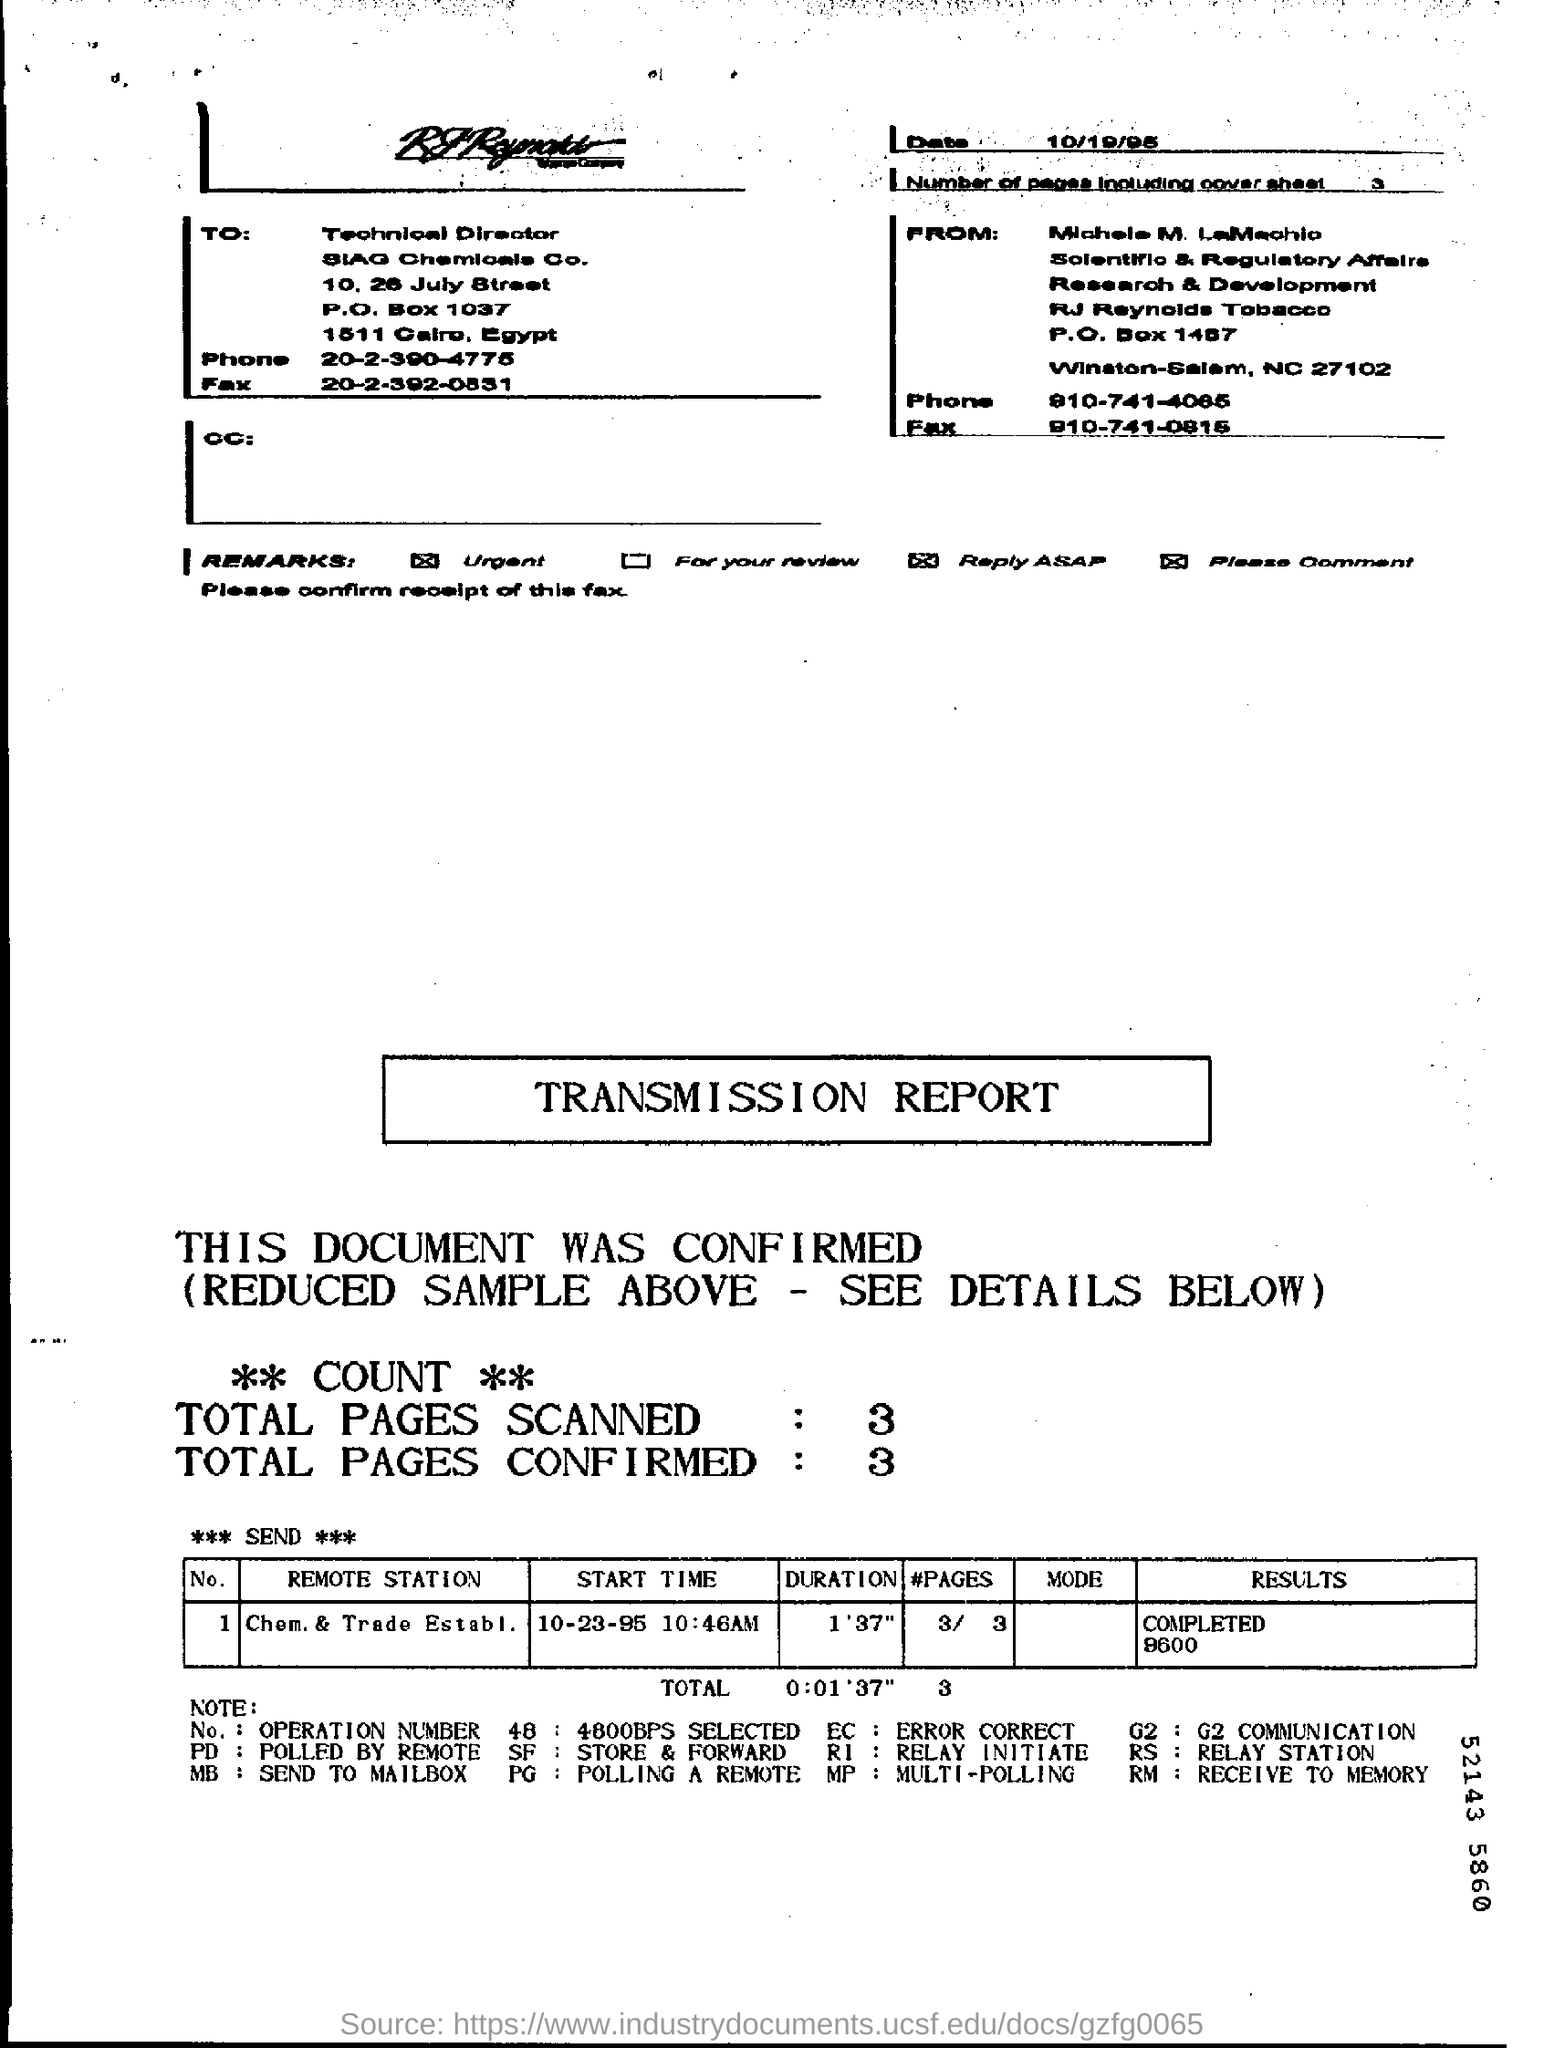What is the date given at the top of the page?
Your answer should be very brief. 10/19/95. Who is the addressee of the REPORT?
Your answer should be compact. Technical Director. What kind of REPORT is this?
Provide a succinct answer. TRANSMISSION REPORT. Mention the "TOTAL PAGES SCANNED"?
Offer a terse response. 3. Mention the "TOTAL PAGES CONFIRMED"?
Your answer should be compact. 3. What is the "REMOTE STATION " for  No.1?
Offer a very short reply. Chem. & trade establ. What is the expansion of PD?
Your answer should be very brief. Polled by remote. What is the expansion of RI?
Provide a succinct answer. RELAY INITIATE. What is the expansion of EC?
Provide a short and direct response. ERROR CORRECT. What is the expansion of SF?
Your answer should be compact. Store & forward. 